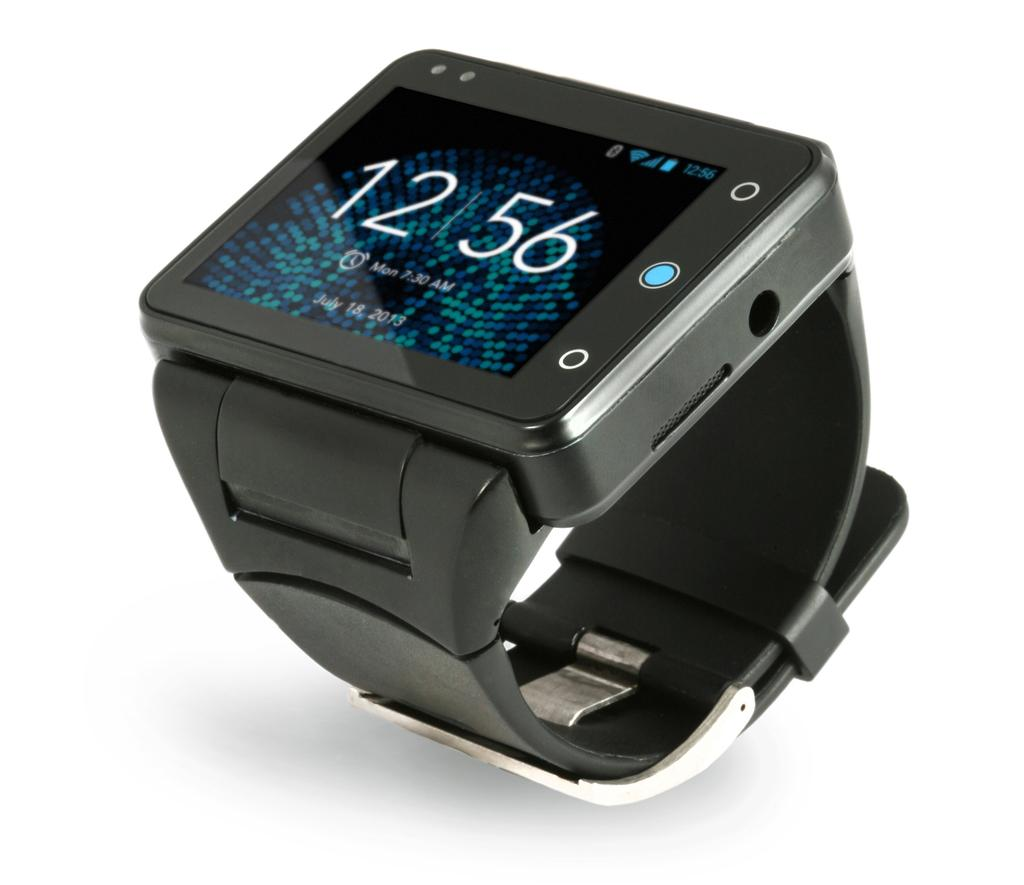<image>
Render a clear and concise summary of the photo. A digital watch screen displays the time of 12:56. 